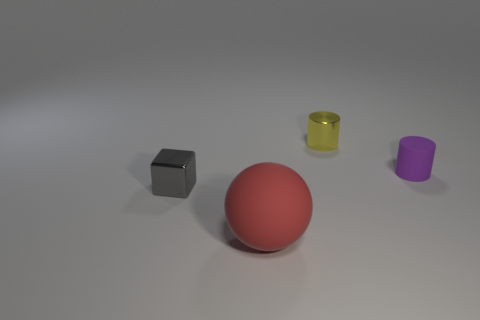Is the material of the object left of the big sphere the same as the yellow cylinder?
Offer a very short reply. Yes. Is the number of small yellow things that are on the right side of the small gray thing the same as the number of metal blocks on the right side of the purple cylinder?
Provide a short and direct response. No. What number of objects are behind the rubber thing that is on the right side of the big object?
Give a very brief answer. 1. Does the tiny thing that is left of the red rubber ball have the same color as the rubber object right of the large rubber ball?
Ensure brevity in your answer.  No. There is a yellow cylinder that is the same size as the gray object; what is it made of?
Provide a succinct answer. Metal. The shiny thing that is to the right of the matte thing that is to the left of the cylinder that is on the left side of the small purple rubber cylinder is what shape?
Offer a very short reply. Cylinder. There is a gray shiny object that is the same size as the yellow metallic cylinder; what is its shape?
Ensure brevity in your answer.  Cube. How many metallic cubes are in front of the shiny object that is in front of the tiny metallic thing that is right of the tiny shiny block?
Provide a succinct answer. 0. Are there more cylinders that are behind the purple object than metal cylinders left of the red rubber object?
Your answer should be compact. Yes. What number of other matte things have the same shape as the large thing?
Make the answer very short. 0. 